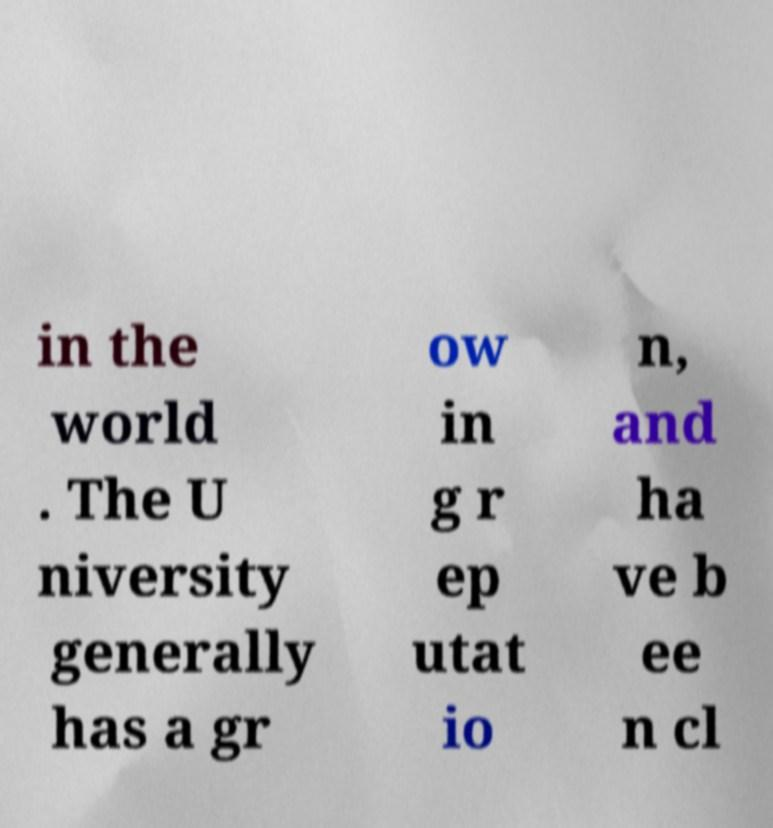Could you assist in decoding the text presented in this image and type it out clearly? in the world . The U niversity generally has a gr ow in g r ep utat io n, and ha ve b ee n cl 